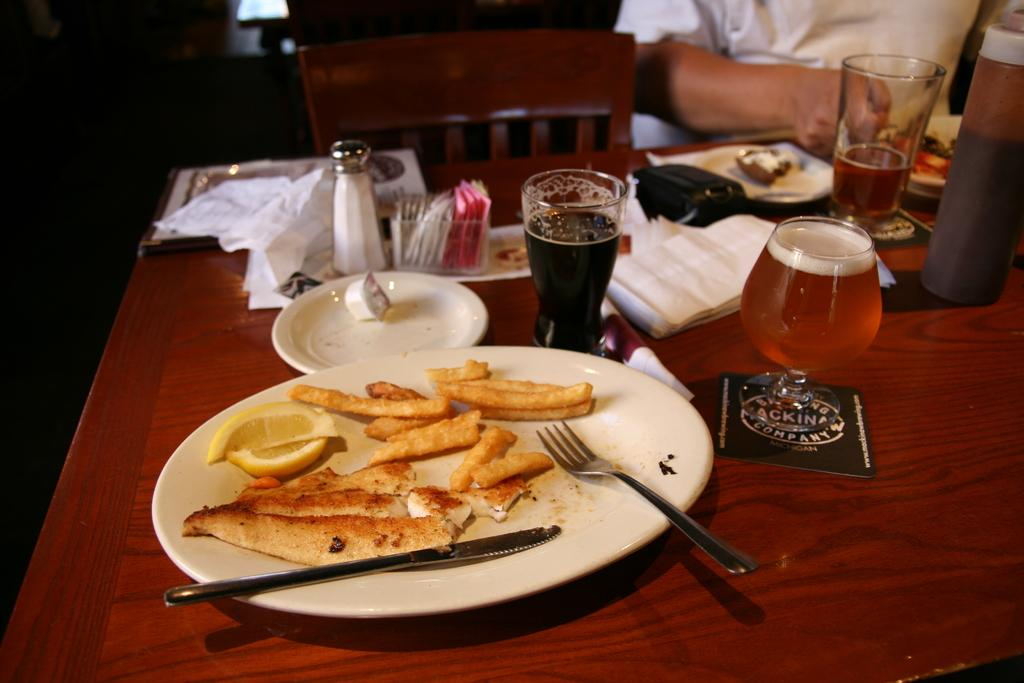What is on the plate that the man is eating from? There are food items on a plate. What utensils are available for the man to use while eating? There is a knife and fork on the table. What is the man drinking from? The man is drinking wine from a wine glass. What is the man's position while eating? The man is sitting on a chair. Where is the salt bottle located on the table? The salt bottle is on the left side of the table. What type of bells can be heard ringing in the image? There are no bells present in the image, and therefore no sound can be heard. 